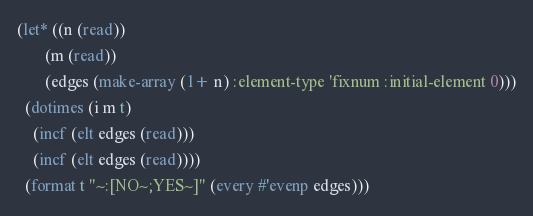<code> <loc_0><loc_0><loc_500><loc_500><_Lisp_>(let* ((n (read))
       (m (read))
       (edges (make-array (1+ n) :element-type 'fixnum :initial-element 0)))
  (dotimes (i m t)
    (incf (elt edges (read)))
    (incf (elt edges (read))))
  (format t "~:[NO~;YES~]" (every #'evenp edges)))</code> 